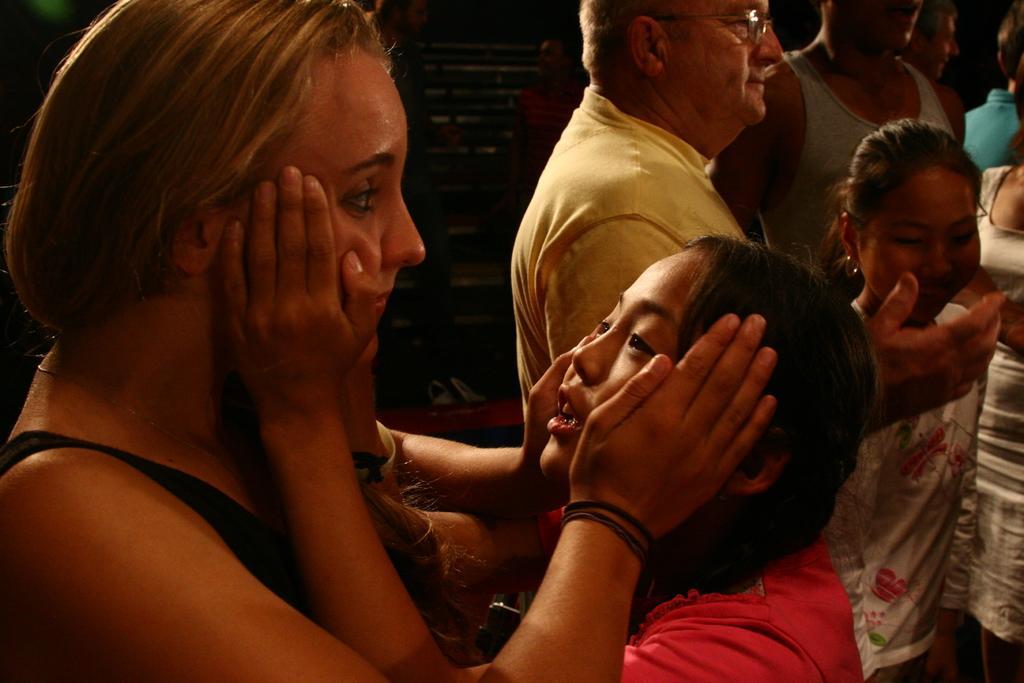Could you give a brief overview of what you see in this image? In the image there are two girls in the foreground and behind them there are some other people. 